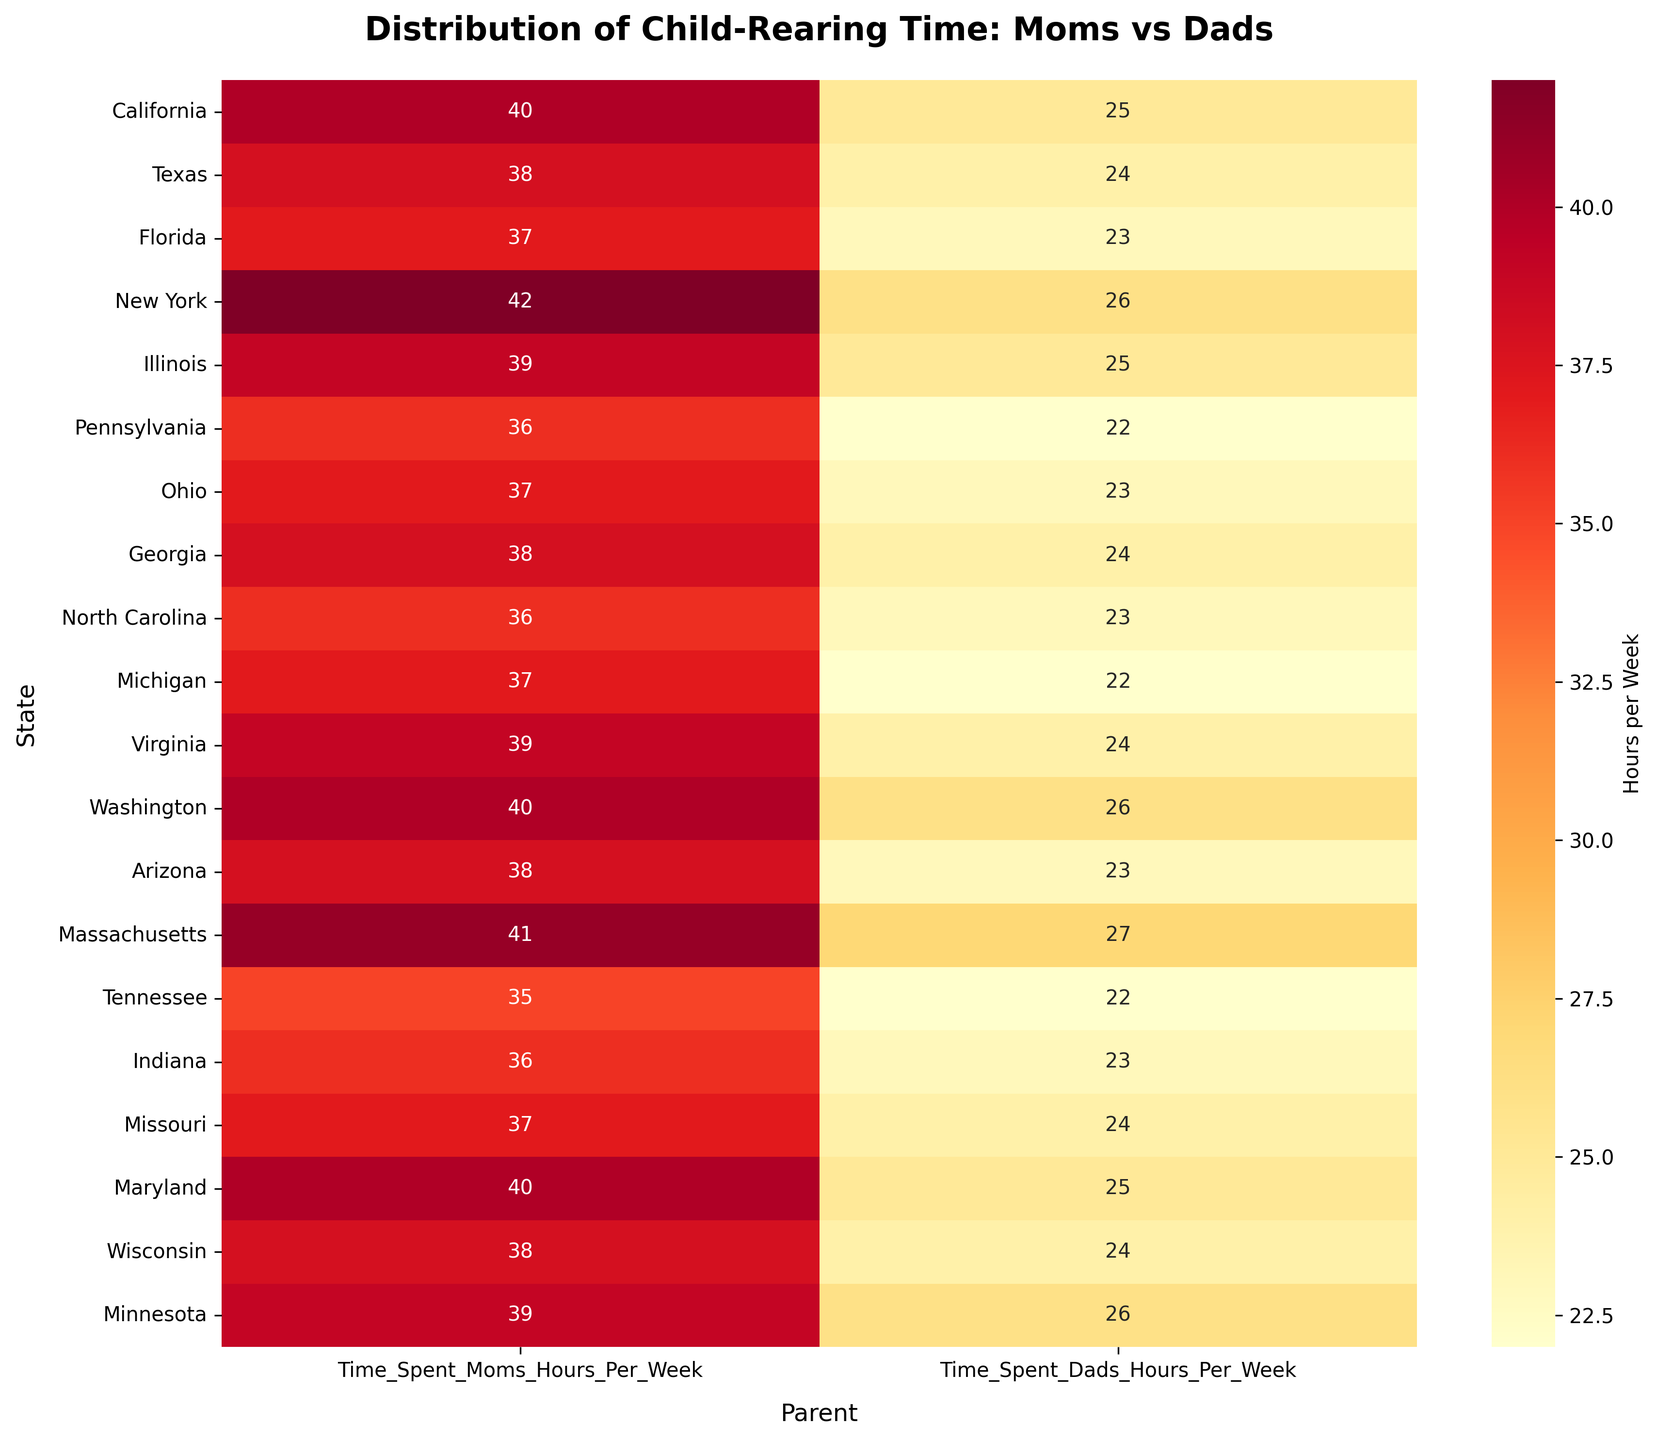What's the title of the figure? The title of the figure is written at the top of the plot. It reads "Distribution of Child-Rearing Time: Moms vs Dads".
Answer: Distribution of Child-Rearing Time: Moms vs Dads Which state shows the highest time spent on child-rearing activities by moms? By examining the value annotations in the heatmap for the "Time_Spent_Moms_Hours_Per_Week" column, we see that New York has the highest value of 42 hours per week.
Answer: New York What is the total time spent on child-rearing activities by both parents combined in Massachusetts? According to the data provided, Massachusetts has 41 hours per week for moms and 27 hours per week for dads. Summing these values results in 41 + 27 = 68 hours per week.
Answer: 68 Which state has the smallest difference in time spent on child-rearing between moms and dads? The difference can be calculated by subtracting the dad's hours from the mom's hours for each state. Washington has the smallest difference of 40 - 26 = 14 hours.
Answer: Washington Do moms generally spend more time on child-rearing activities than dads across all states? By observing the trends in the heatmap, all states show higher values in the "Time_Spent_Moms_Hours_Per_Week" column compared to the "Time_Spent_Dads_Hours_Per_Week" column.
Answer: Yes What's the average time spent by dads on child-rearing activities across all states? To find the average, add all the dad's hours and divide by the number of states. (25 + 24 + 23 + 26 + 25 + 22 + 23 + 24 + 23 + 22 + 24 + 26 + 23 + 27 + 22 + 23 + 24 + 25 + 26)/19 = 23.79, rounded to 24 hours.
Answer: 24 Which state has the maximum combined total hours per week on child-rearing activities? According to the data, both New York and Massachusetts show a combined total of 68 hours per week, which is the highest.
Answer: New York and Massachusetts 